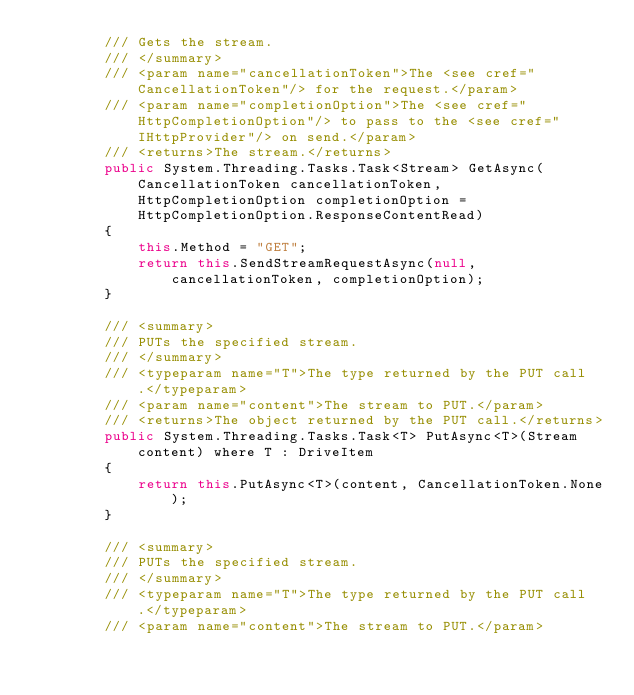<code> <loc_0><loc_0><loc_500><loc_500><_C#_>        /// Gets the stream.
        /// </summary>
        /// <param name="cancellationToken">The <see cref="CancellationToken"/> for the request.</param>
        /// <param name="completionOption">The <see cref="HttpCompletionOption"/> to pass to the <see cref="IHttpProvider"/> on send.</param>
        /// <returns>The stream.</returns>
        public System.Threading.Tasks.Task<Stream> GetAsync(CancellationToken cancellationToken, HttpCompletionOption completionOption = HttpCompletionOption.ResponseContentRead)
        {
            this.Method = "GET";
            return this.SendStreamRequestAsync(null, cancellationToken, completionOption);
        }
    
        /// <summary>
        /// PUTs the specified stream.
        /// </summary>
        /// <typeparam name="T">The type returned by the PUT call.</typeparam>
        /// <param name="content">The stream to PUT.</param>
        /// <returns>The object returned by the PUT call.</returns>
        public System.Threading.Tasks.Task<T> PutAsync<T>(Stream content) where T : DriveItem
        {
            return this.PutAsync<T>(content, CancellationToken.None);
        }

        /// <summary>
        /// PUTs the specified stream.
        /// </summary>
        /// <typeparam name="T">The type returned by the PUT call.</typeparam>
        /// <param name="content">The stream to PUT.</param></code> 